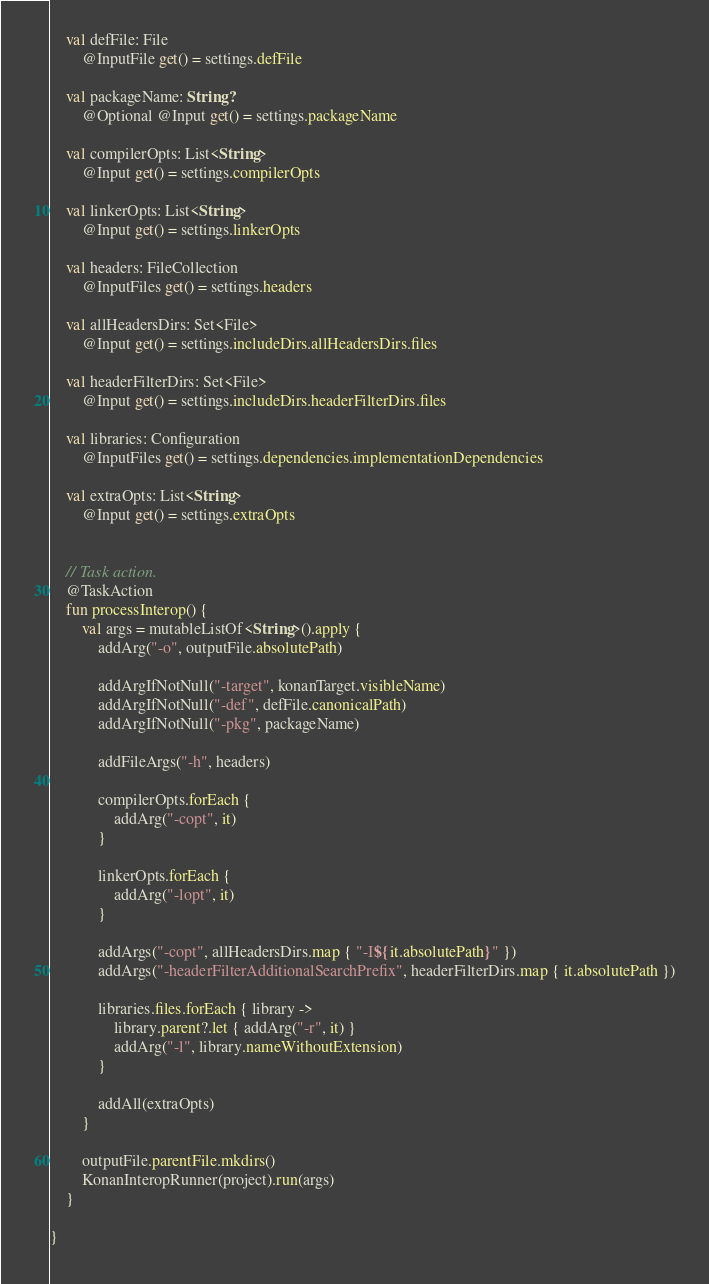Convert code to text. <code><loc_0><loc_0><loc_500><loc_500><_Kotlin_>
    val defFile: File
        @InputFile get() = settings.defFile

    val packageName: String?
        @Optional @Input get() = settings.packageName

    val compilerOpts: List<String>
        @Input get() = settings.compilerOpts

    val linkerOpts: List<String>
        @Input get() = settings.linkerOpts

    val headers: FileCollection
        @InputFiles get() = settings.headers

    val allHeadersDirs: Set<File>
        @Input get() = settings.includeDirs.allHeadersDirs.files

    val headerFilterDirs: Set<File>
        @Input get() = settings.includeDirs.headerFilterDirs.files

    val libraries: Configuration
        @InputFiles get() = settings.dependencies.implementationDependencies

    val extraOpts: List<String>
        @Input get() = settings.extraOpts


    // Task action.
    @TaskAction
    fun processInterop() {
        val args = mutableListOf<String>().apply {
            addArg("-o", outputFile.absolutePath)

            addArgIfNotNull("-target", konanTarget.visibleName)
            addArgIfNotNull("-def", defFile.canonicalPath)
            addArgIfNotNull("-pkg", packageName)

            addFileArgs("-h", headers)

            compilerOpts.forEach {
                addArg("-copt", it)
            }

            linkerOpts.forEach {
                addArg("-lopt", it)
            }

            addArgs("-copt", allHeadersDirs.map { "-I${it.absolutePath}" })
            addArgs("-headerFilterAdditionalSearchPrefix", headerFilterDirs.map { it.absolutePath })

            libraries.files.forEach { library ->
                library.parent?.let { addArg("-r", it) }
                addArg("-l", library.nameWithoutExtension)
            }

            addAll(extraOpts)
        }

        outputFile.parentFile.mkdirs()
        KonanInteropRunner(project).run(args)
    }

}</code> 